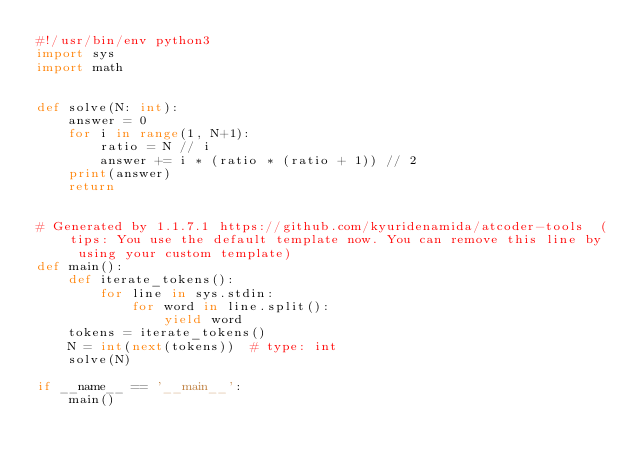Convert code to text. <code><loc_0><loc_0><loc_500><loc_500><_Python_>#!/usr/bin/env python3
import sys
import math


def solve(N: int):
    answer = 0
    for i in range(1, N+1):
        ratio = N // i
        answer += i * (ratio * (ratio + 1)) // 2
    print(answer)
    return


# Generated by 1.1.7.1 https://github.com/kyuridenamida/atcoder-tools  (tips: You use the default template now. You can remove this line by using your custom template)
def main():
    def iterate_tokens():
        for line in sys.stdin:
            for word in line.split():
                yield word
    tokens = iterate_tokens()
    N = int(next(tokens))  # type: int
    solve(N)

if __name__ == '__main__':
    main()
</code> 